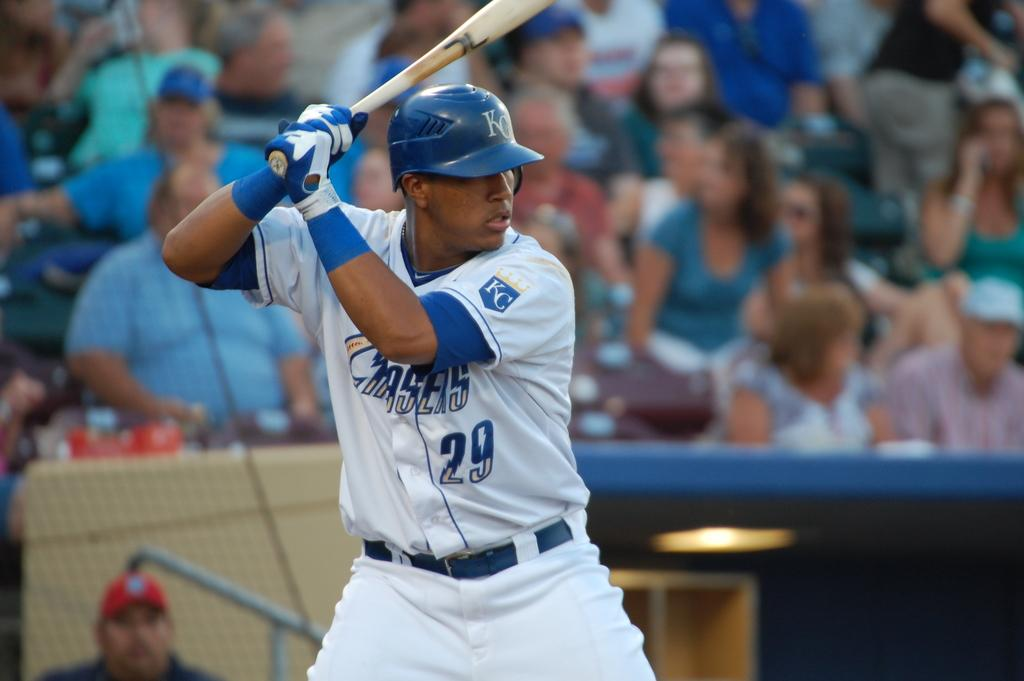What is the man in the image doing? The man is standing in the image and holding a bat. What protective gear is the man wearing? The man is wearing a helmet and gloves. Can you describe the people visible in the background of the image? There are people visible in the background of the image, but their specific actions or appearances are not mentioned in the provided facts. What type of lead is the man using to hit the cars in the image? There are no cars or lead present in the image; the man is holding a bat. What type of metal is the man using to hit the cars in the image? There are no cars or metal objects present in the image; the man is holding a bat. 